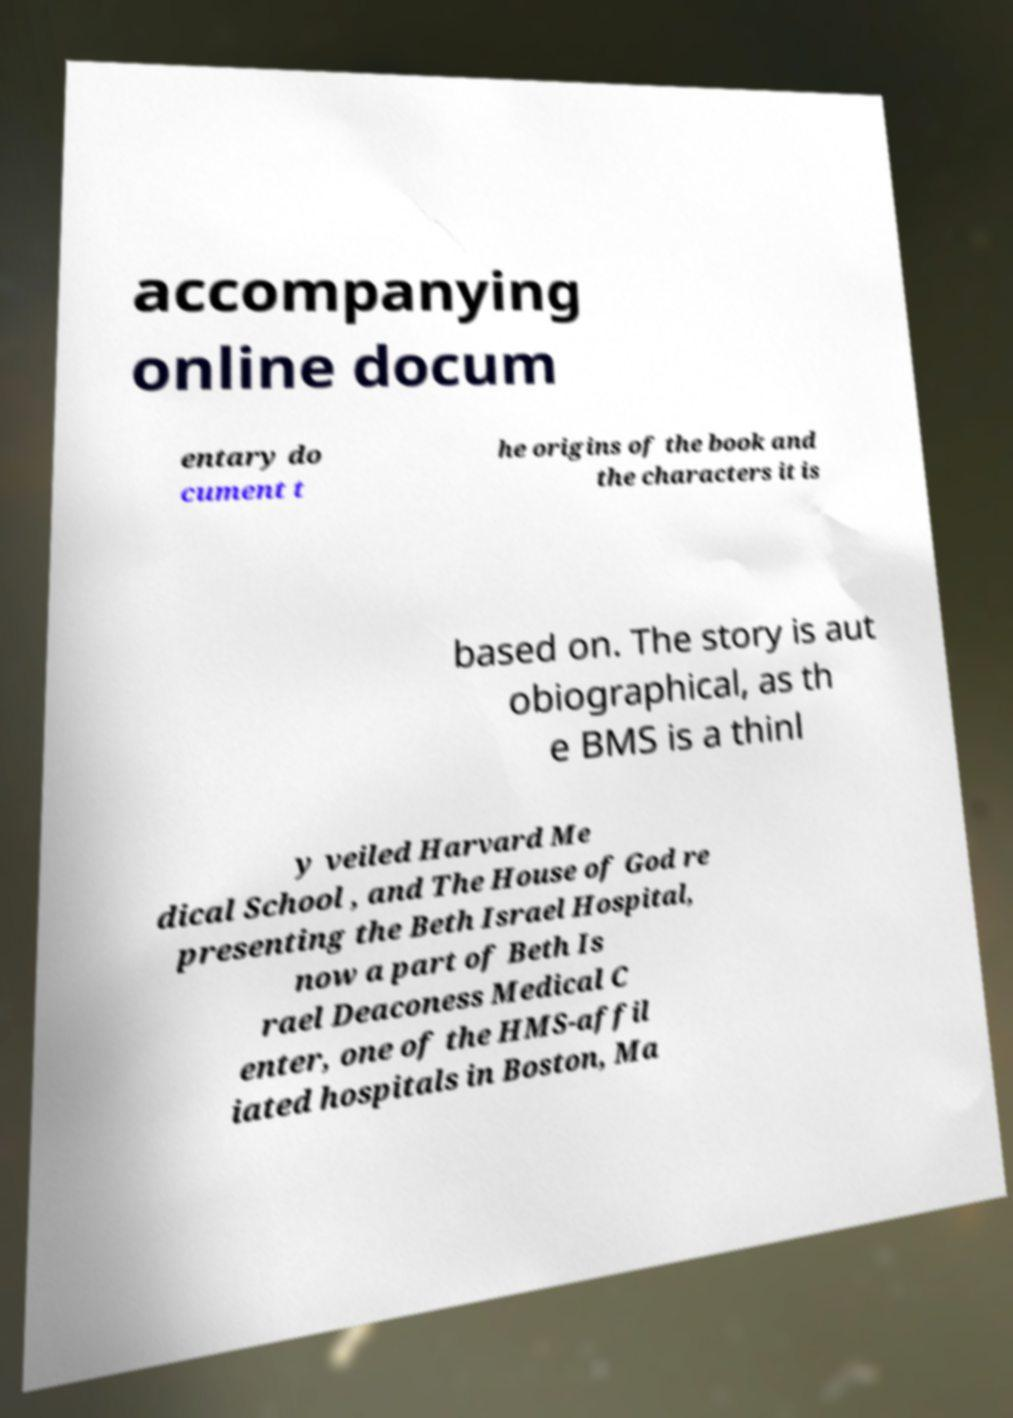Could you extract and type out the text from this image? accompanying online docum entary do cument t he origins of the book and the characters it is based on. The story is aut obiographical, as th e BMS is a thinl y veiled Harvard Me dical School , and The House of God re presenting the Beth Israel Hospital, now a part of Beth Is rael Deaconess Medical C enter, one of the HMS-affil iated hospitals in Boston, Ma 